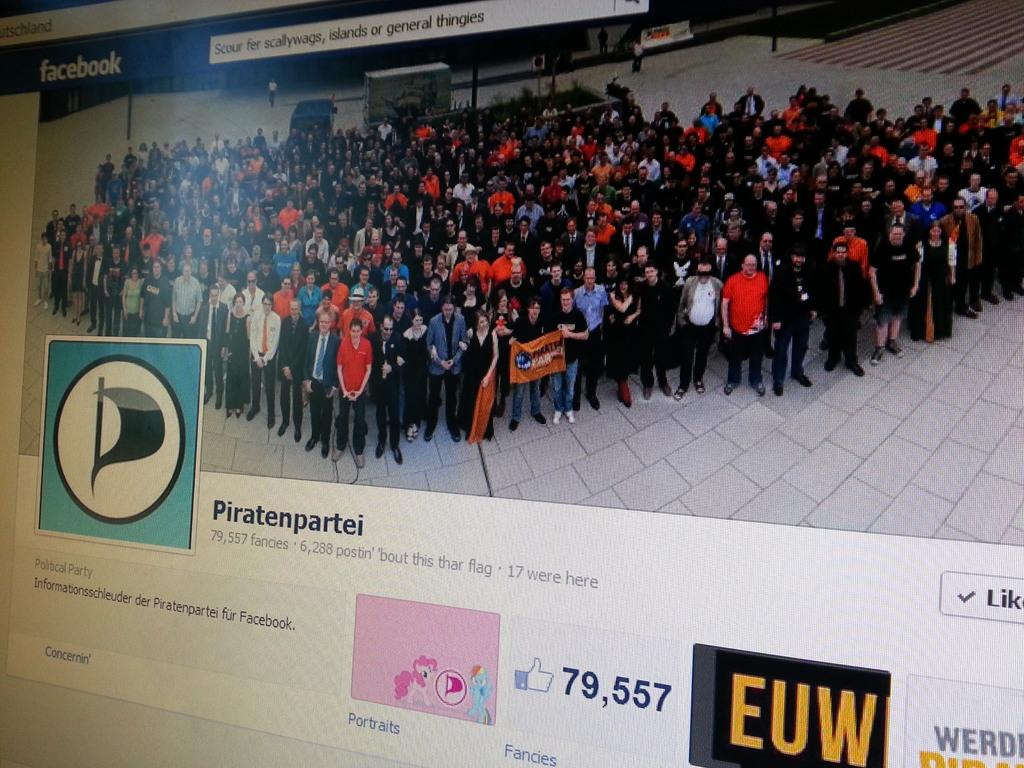<image>
Present a compact description of the photo's key features. Piratenpartei has a facebook with the cover showing many people standing up. 